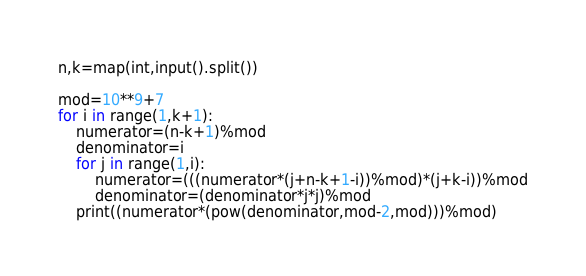<code> <loc_0><loc_0><loc_500><loc_500><_Python_>n,k=map(int,input().split())

mod=10**9+7
for i in range(1,k+1):
    numerator=(n-k+1)%mod
    denominator=i
    for j in range(1,i):
        numerator=(((numerator*(j+n-k+1-i))%mod)*(j+k-i))%mod
        denominator=(denominator*j*j)%mod
    print((numerator*(pow(denominator,mod-2,mod)))%mod)</code> 